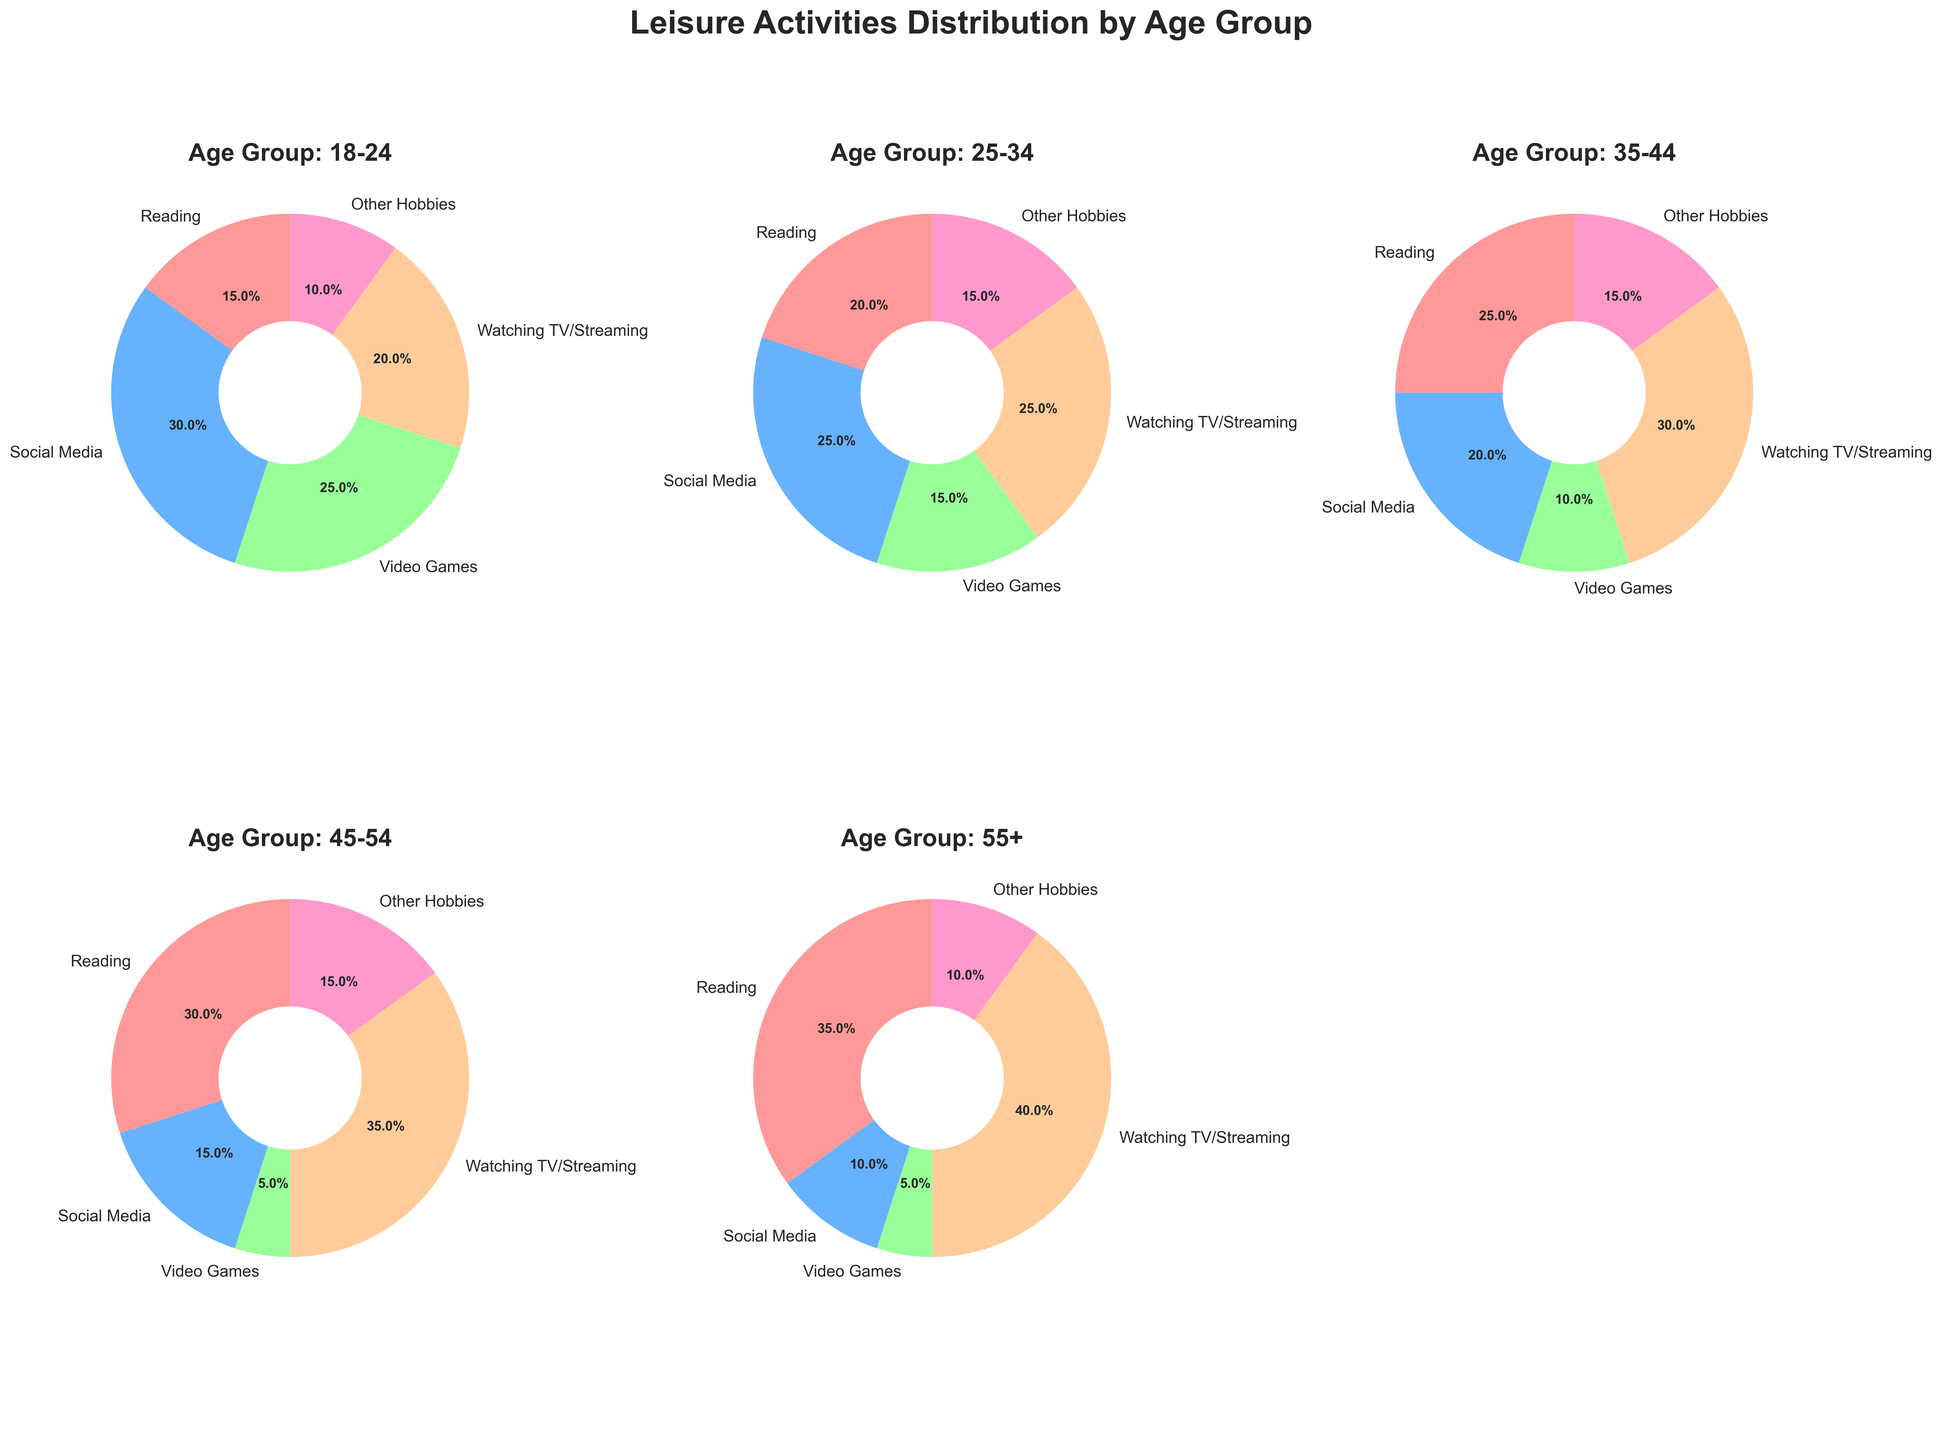Which age group spends the highest percentage of time reading? To determine the age group that spends the highest percentage of time reading, examine each pie chart and compare the slices representing reading. The 55+ age group has the largest reading slice at 35%.
Answer: 55+ What is the combined percentage of time spent on social media and video games for the 18-24 age group? Refer to the pie chart for the 18-24 age group. Add the percentages for social media (30%) and video games (25%). The combined percentage is 30% + 25% = 55%.
Answer: 55% Which age group spends the least time on video games, and what is the percentage? Examine the pie charts to identify the smallest video game slice. The 45-54 and 55+ age groups both have the smallest video game slice at 5%.
Answer: 45-54 and 55+ at 5% How does the percentage of time spent on watching TV/streaming change as the age groups increase? Observe the slices for watching TV/streaming across the different age group pie charts: 18-24 (20%), 25-34 (25%), 35-44 (30%), 45-54 (35%), and 55+ (40%). The percentage consistently increases with age.
Answer: Increases with age What is the average percentage of time spent on other hobbies across all age groups? Add the percentages for other hobbies for all age groups: 10% (18-24), 15% (25-34), 15% (35-44), 15% (45-54), and 10% (55+). Then, divide by the number of age groups (5). The calculation is (10% + 15% + 15% + 15% + 10%) / 5 = 13%.
Answer: 13% Which age group has the highest combined percentage of time for reading and other hobbies? Determine the combined percentages for reading and other hobbies in each age group: 18-24 (15% + 10% = 25%), 25-34 (20% + 15% = 35%), 35-44 (25% + 15% = 40%), 45-54 (30% + 15% = 45%), and 55+ (35% + 10% = 45%). The 45-54 and 55+ age groups are tied with 45%.
Answer: 45-54 and 55+ at 45% Between the 25-34 and 35-44 age groups, which one has a higher percentage of social media usage, and by how much? Compare the social media slices for the 25-34 (25%) and 35-44 (20%) age groups. The 25-34 age group spends 5% more time on social media.
Answer: 25-34 age group by 5% For the 18-24 age group, what is the difference in percentage between social media and watching TV/streaming? Subtract the percentage for watching TV/streaming (20%) from that for social media (30%). The difference is 30% - 20% = 10%.
Answer: 10% 